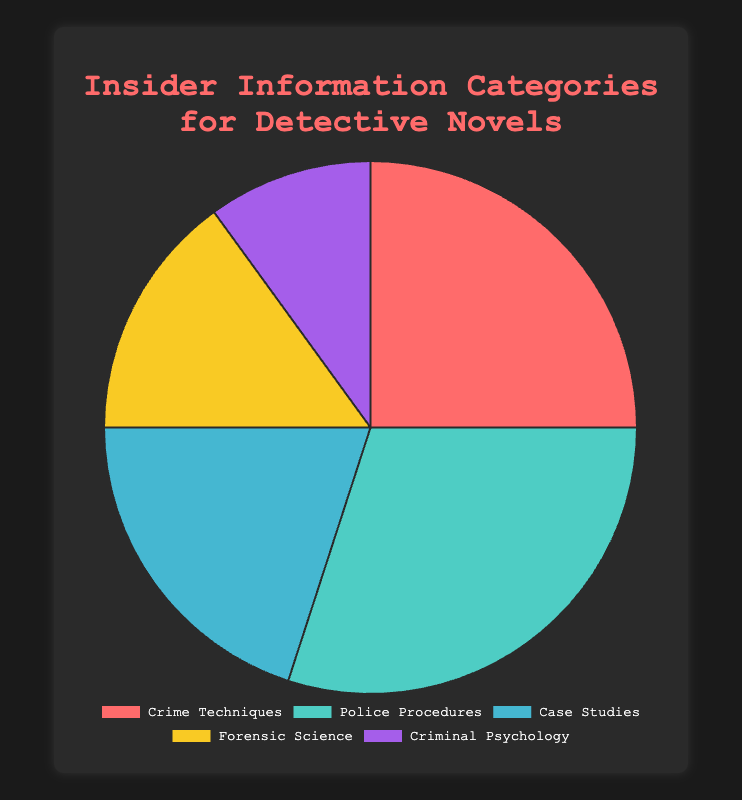Which category provides the largest percentage of insider information? The figure shows that the largest percentage of insider information comes from the "Police Procedures" category, which takes up the most significant portion of the pie chart.
Answer: Police Procedures How much more does the "Crime Techniques" category contribute to insider information than the "Criminal Psychology" category? The "Crime Techniques" category contributes 25%, while the "Criminal Psychology" category contributes 10%. The difference is 25% - 10% = 15%.
Answer: 15% Which two categories together make up half of the insider information? The two categories that make up half of the insider information are "Police Procedures" (30%) and "Crime Techniques" (25%). Together, they sum up to 55%, more than half.
Answer: Police Procedures, Crime Techniques What is the combined percentage of the "Case Studies" and "Forensic Science" categories? The "Case Studies" category contributes 20%, and the "Forensic Science" category contributes 15%. Their combined percentage is 20% + 15% = 35%.
Answer: 35% Which category contributes the least to insider information? The pie chart shows that "Criminal Psychology" contributes the smallest portion, which is 10%.
Answer: Criminal Psychology Are there any two categories that contribute the same percentage of insider information? By inspecting the pie chart, none of the categories contribute the same percentage. All values (25%, 30%, 20%, 15%, and 10%) are distinct.
Answer: No What is the percentage difference between the highest and lowest contributing categories? The highest contributing category is "Police Procedures" at 30%, and the lowest is "Criminal Psychology" at 10%. The difference is 30% - 10% = 20%.
Answer: 20% What color represents the "Case Studies" category in the chart? The "Case Studies" section of the pie chart is represented in a blue color.
Answer: Blue 